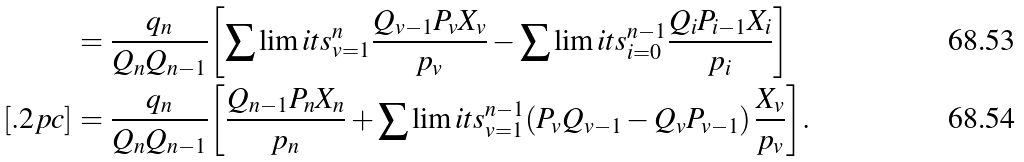<formula> <loc_0><loc_0><loc_500><loc_500>& = { \frac { { q _ { n } } } { { Q _ { n } Q _ { n - 1 } } } } { \left [ { { \sum \lim i t s _ { v = 1 } ^ { n } { { \frac { { Q _ { v - 1 } P _ { v } X _ { v } } } { { p _ { v } } } } } } - { \sum \lim i t s _ { i = 0 } ^ { n - 1 } { { \frac { { Q _ { i } P _ { i - 1 } X _ { i } } } { { p _ { i } } } } } } } \right ] } \\ [ . 2 p c ] & = { \frac { { q _ { n } } } { { Q _ { n } Q _ { n - 1 } } } } { \left [ { { \frac { { Q _ { n - 1 } P _ { n } X _ { n } } } { { p _ { n } } } } + { \sum \lim i t s _ { v = 1 } ^ { n - 1 } { \left ( { P _ { v } Q _ { v - 1 } - Q _ { v } P _ { v - 1 } } \right ) { \frac { { X _ { v } } } { { p _ { v } } } } } } } \right ] } .</formula> 